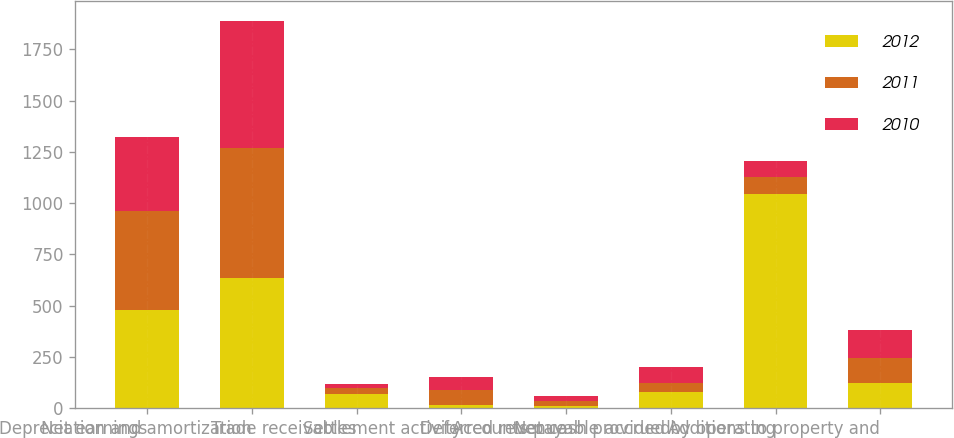<chart> <loc_0><loc_0><loc_500><loc_500><stacked_bar_chart><ecel><fcel>Net earnings<fcel>Depreciation and amortization<fcel>Trade receivables<fcel>Settlement activity<fcel>Deferred revenue<fcel>Accounts payable accrued<fcel>Net cash provided by operating<fcel>Additions to property and<nl><fcel>2012<fcel>481.1<fcel>632.8<fcel>68<fcel>16.8<fcel>11.1<fcel>79.5<fcel>1046.7<fcel>123.7<nl><fcel>2011<fcel>481.1<fcel>637.2<fcel>31<fcel>71.9<fcel>25.5<fcel>41.9<fcel>79.75<fcel>123.9<nl><fcel>2010<fcel>357.9<fcel>619.5<fcel>21.3<fcel>61.8<fcel>25.3<fcel>80<fcel>79.75<fcel>132.8<nl></chart> 